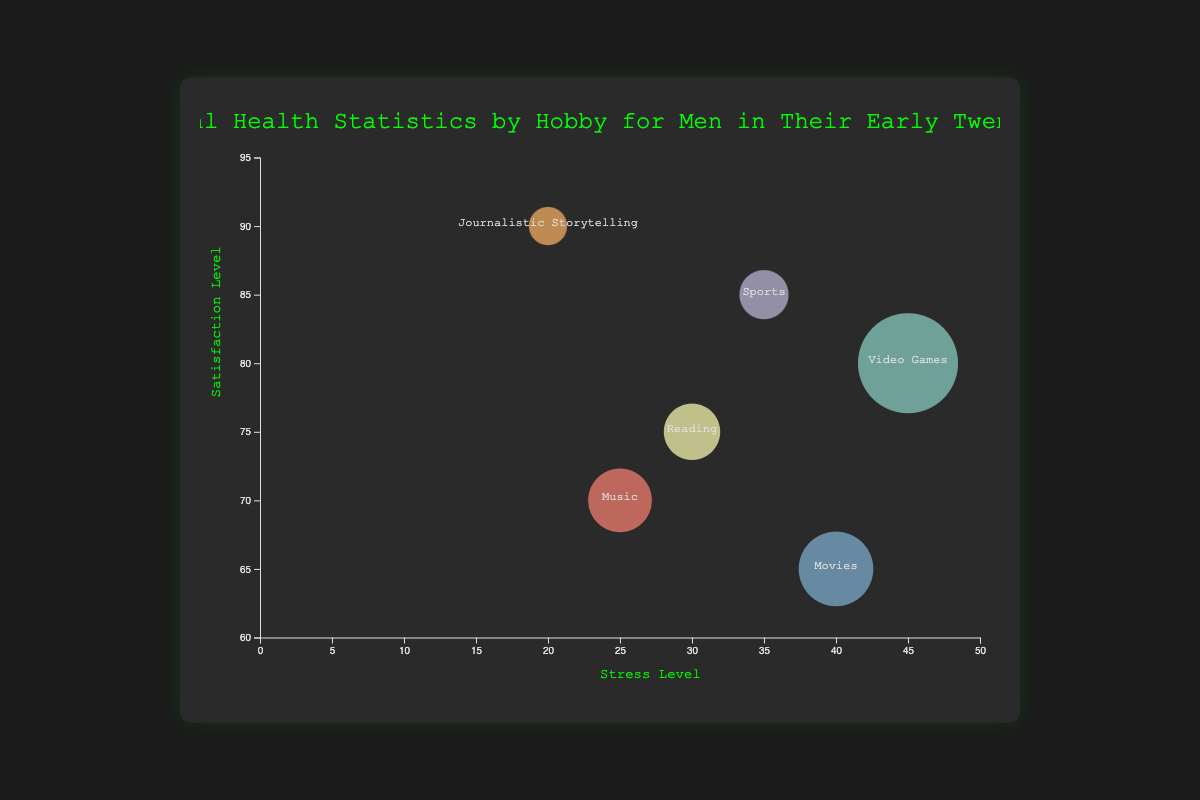what is the title of the chart? The title of the chart is displayed at the top and reads "Mental Health Statistics by Hobby for Men in Their Early Twenties".
Answer: Mental Health Statistics by Hobby for Men in Their Early Twenties How many hobbies are represented in the chart? By counting the number of unique bubbles, we can determine that there are six different hobbies displayed.
Answer: 6 Which hobby has the lowest stress level? By identifying the circle located furthest to the left on the X-axis, which represents stress level, we see that Journalistic Storytelling has the lowest stress level.
Answer: Journalistic Storytelling Which hobby has the highest satisfaction level? By identifying the circle located highest on the Y-axis, which represents satisfaction level, we see that Journalistic Storytelling has the highest satisfaction level.
Answer: Journalistic Storytelling Compare the average hours per week spent on Video Games and on Reading. Which hobby has more hours? To find this, we compare the size of the bubbles for Video Games and Reading. Video Games has a larger bubble, indicating more average hours per week.
Answer: Video Games What is the average satisfaction level of Reading and Sports? The satisfaction level for Reading is 75 and for Sports is 85. The average of these two values is (75 + 85) / 2 = 80.
Answer: 80 Which hobby has higher stress levels, Movies or Music? By looking at the X-axis position of the bubbles for Movies and Music, Movies is further right, indicating higher stress levels.
Answer: Movies Which hobby is indicated by the bubble with the largest radius? The hobby indicated by the bubble with the largest radius is Video Games, as it corresponds to the highest average hours per week.
Answer: Video Games Which hobby has lower stress levels, Reading or Sports? By looking at the X-axis position of the bubbles for Reading and Sports, Reading is further left, indicating lower stress levels.
Answer: Reading Rank the hobbies by their satisfaction levels in ascending order. The satisfaction levels are as follows: Movies (65), Music (70), Reading (75), Video Games (80), Sports (85), Journalistic Storytelling (90). Arranging them in ascending order gives the ranking: Movies, Music, Reading, Video Games, Sports, Journalistic Storytelling.
Answer: Movies, Music, Reading, Video Games, Sports, Journalistic Storytelling 